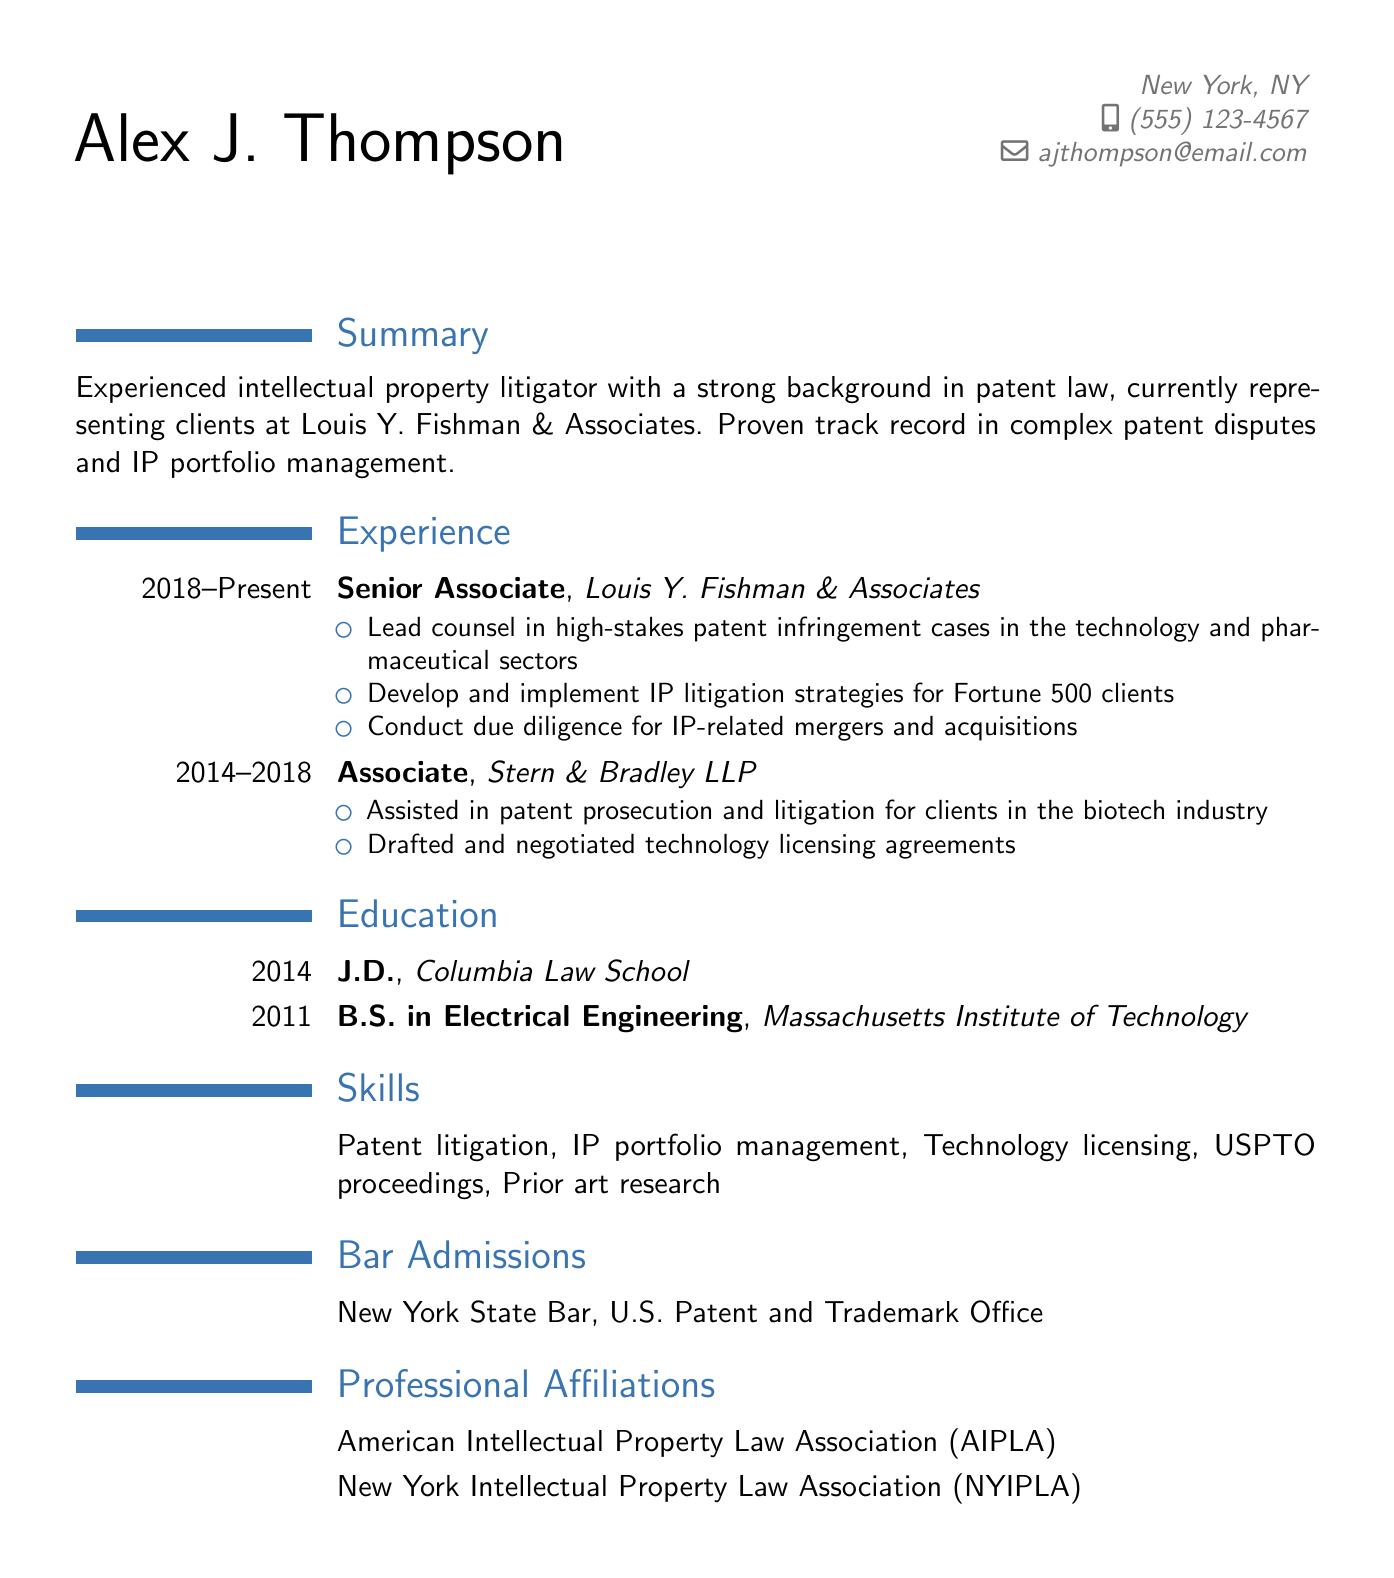What is the name of the individual? The name is stated in the personal information section of the document.
Answer: Alex J. Thompson What is the current position held by Alex J. Thompson? The current position is given in the experience section of the document.
Answer: Senior Associate In what year did Alex J. Thompson graduate from Columbia Law School? The year of graduation is listed in the education section.
Answer: 2014 What companies has Alex J. Thompson worked for? The companies are mentioned in the experience section.
Answer: Louis Y. Fishman & Associates; Stern & Bradley LLP How many years did Alex J. Thompson work at Stern & Bradley LLP? The duration of work is indicated in the experience section.
Answer: 4 years What is one of the skills listed in the resume? Skills are specified in the skills section of the document.
Answer: Patent litigation Which bar admission is held by Alex J. Thompson? Bar admissions are listed in the respective section of the document.
Answer: New York State Bar What is the highest degree obtained by Alex J. Thompson? The highest degree is mentioned in the education section.
Answer: J.D What professional affiliation does Alex J. Thompson belong to? The professional affiliations are provided in the respective section of the document.
Answer: American Intellectual Property Law Association (AIPLA) What area of law does Alex J. Thompson specialize in? The area of specialization is identified in the summary section.
Answer: Intellectual property litigation 